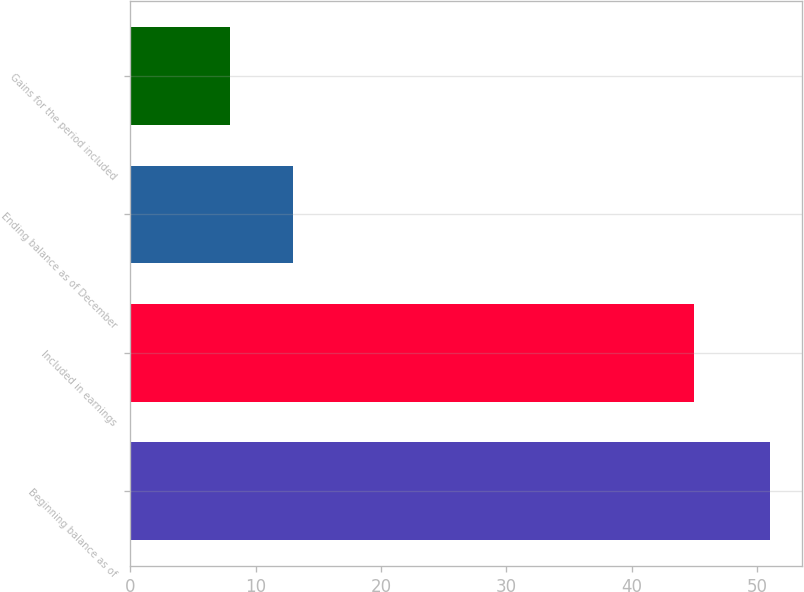<chart> <loc_0><loc_0><loc_500><loc_500><bar_chart><fcel>Beginning balance as of<fcel>Included in earnings<fcel>Ending balance as of December<fcel>Gains for the period included<nl><fcel>51<fcel>45<fcel>13<fcel>8<nl></chart> 